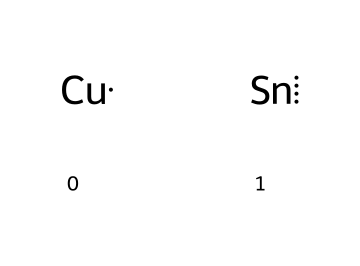how many different elements are present in the chemical? The SMILES representation shows two distinct elements: copper and tin. Thus, the total number of different elements is two.
Answer: two what is the name of the compound represented? The combination of copper and tin specifically forms the alloy known as bronze. Therefore, the name of the compound is bronze.
Answer: bronze which element in the compound is a transition metal? In the chemical representation, copper is classified as a transition metal, while tin is not. Transition metals are generally found in the d-block of the periodic table, and copper fits this category.
Answer: copper what kind of bond exists between the elements in this compound? The elements in this compound form metallic bonds, which are characterized by a sea of delocalized electrons allowing for conductivity and malleability, typical for metals.
Answer: metallic how does this chemical composition contribute to making musical instruments? The alloy of copper and tin, known as bronze, offers durability and a pleasing acoustic quality, making it suitable for producing clear, rich sounds in musical instruments such as harmonicas.
Answer: durability and acoustic quality what is the percentage composition of copper in bronze? The typical composition of bronze varies, but it is commonly around 88% copper and 12% tin. This ratio provides the desired properties of the alloy. Therefore, the percentage of copper is roughly 88%.
Answer: 88% explain why this compound is classified as a coordination compound. In a broader sense, coordination compounds involve metals bonded with ligands. While bronze itself is a metallic alloy, the concept of coordination can be linked to the arrangement and interaction of the copper and tin atoms within its structure, thus leading to its functional properties.
Answer: metallic alloy 